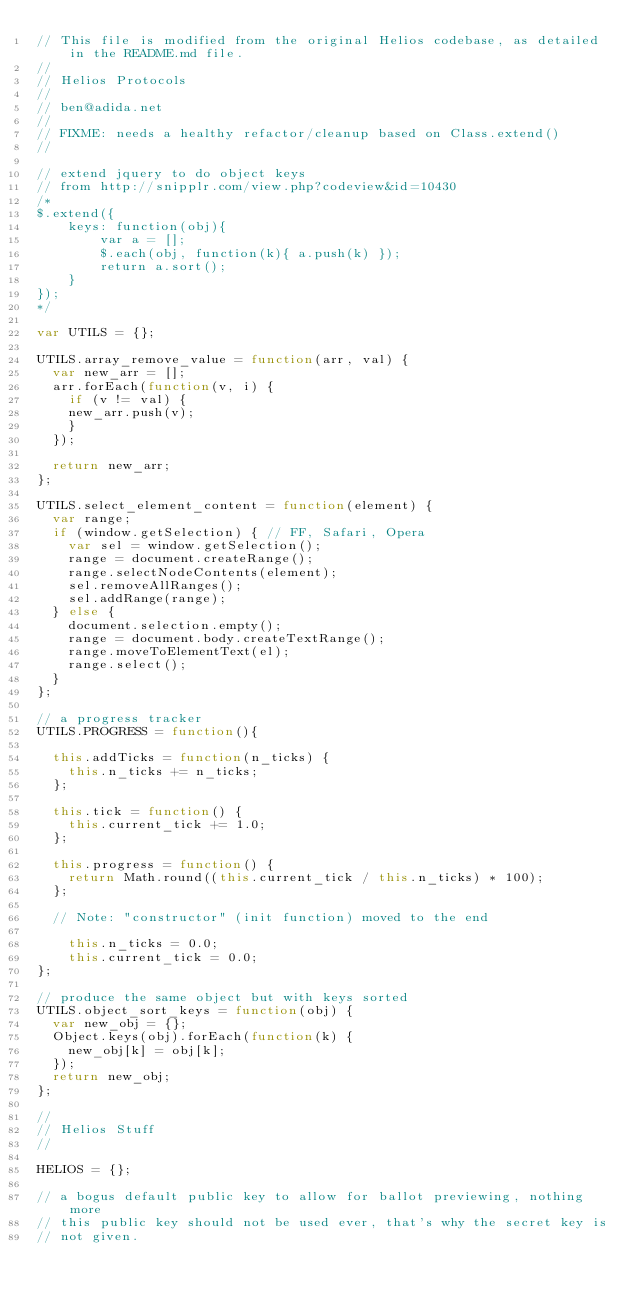<code> <loc_0><loc_0><loc_500><loc_500><_JavaScript_>// This file is modified from the original Helios codebase, as detailed in the README.md file.
//
// Helios Protocols
// 
// ben@adida.net
//
// FIXME: needs a healthy refactor/cleanup based on Class.extend()
//

// extend jquery to do object keys
// from http://snipplr.com/view.php?codeview&id=10430
/*
$.extend({
    keys: function(obj){
        var a = [];
        $.each(obj, function(k){ a.push(k) });
        return a.sort();
    }
});
*/

var UTILS = {};

UTILS.array_remove_value = function(arr, val) {
  var new_arr = [];
  arr.forEach(function(v, i) {
    if (v != val) {
	new_arr.push(v);
    }
  });

  return new_arr;
};

UTILS.select_element_content = function(element) {
  var range;
  if (window.getSelection) { // FF, Safari, Opera
    var sel = window.getSelection();
    range = document.createRange();
    range.selectNodeContents(element);
    sel.removeAllRanges();
    sel.addRange(range);
  } else {
    document.selection.empty();
    range = document.body.createTextRange();
    range.moveToElementText(el);
    range.select();
  }
};

// a progress tracker
UTILS.PROGRESS = function(){
 
  this.addTicks = function(n_ticks) {
    this.n_ticks += n_ticks;
  };
  
  this.tick = function() {
    this.current_tick += 1.0;
  };
  
  this.progress = function() {
    return Math.round((this.current_tick / this.n_ticks) * 100);
  };

  // Note: "constructor" (init function) moved to the end

    this.n_ticks = 0.0;
    this.current_tick = 0.0;
};

// produce the same object but with keys sorted
UTILS.object_sort_keys = function(obj) {
  var new_obj = {};
  Object.keys(obj).forEach(function(k) {
    new_obj[k] = obj[k];
  });
  return new_obj;
};

//
// Helios Stuff
//

HELIOS = {};

// a bogus default public key to allow for ballot previewing, nothing more
// this public key should not be used ever, that's why the secret key is 
// not given.</code> 